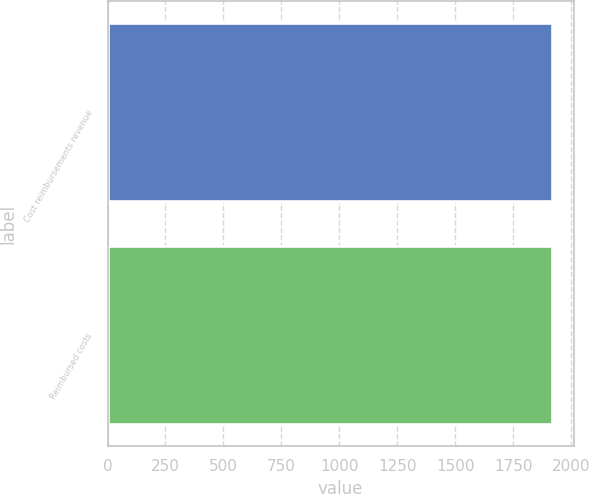Convert chart to OTSL. <chart><loc_0><loc_0><loc_500><loc_500><bar_chart><fcel>Cost reimbursements revenue<fcel>Reimbursed costs<nl><fcel>1916<fcel>1916.1<nl></chart> 